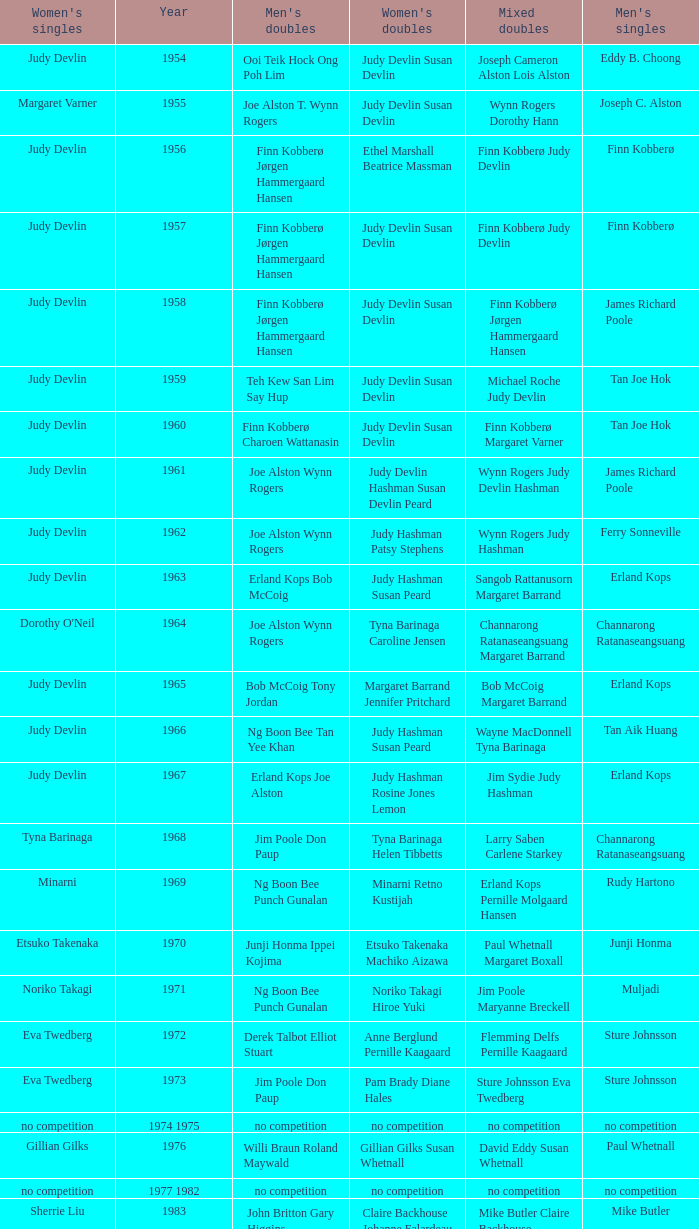Who were the men's doubles champions when the men's singles champion was muljadi? Ng Boon Bee Punch Gunalan. Can you give me this table as a dict? {'header': ["Women's singles", 'Year', "Men's doubles", "Women's doubles", 'Mixed doubles', "Men's singles"], 'rows': [['Judy Devlin', '1954', 'Ooi Teik Hock Ong Poh Lim', 'Judy Devlin Susan Devlin', 'Joseph Cameron Alston Lois Alston', 'Eddy B. Choong'], ['Margaret Varner', '1955', 'Joe Alston T. Wynn Rogers', 'Judy Devlin Susan Devlin', 'Wynn Rogers Dorothy Hann', 'Joseph C. Alston'], ['Judy Devlin', '1956', 'Finn Kobberø Jørgen Hammergaard Hansen', 'Ethel Marshall Beatrice Massman', 'Finn Kobberø Judy Devlin', 'Finn Kobberø'], ['Judy Devlin', '1957', 'Finn Kobberø Jørgen Hammergaard Hansen', 'Judy Devlin Susan Devlin', 'Finn Kobberø Judy Devlin', 'Finn Kobberø'], ['Judy Devlin', '1958', 'Finn Kobberø Jørgen Hammergaard Hansen', 'Judy Devlin Susan Devlin', 'Finn Kobberø Jørgen Hammergaard Hansen', 'James Richard Poole'], ['Judy Devlin', '1959', 'Teh Kew San Lim Say Hup', 'Judy Devlin Susan Devlin', 'Michael Roche Judy Devlin', 'Tan Joe Hok'], ['Judy Devlin', '1960', 'Finn Kobberø Charoen Wattanasin', 'Judy Devlin Susan Devlin', 'Finn Kobberø Margaret Varner', 'Tan Joe Hok'], ['Judy Devlin', '1961', 'Joe Alston Wynn Rogers', 'Judy Devlin Hashman Susan Devlin Peard', 'Wynn Rogers Judy Devlin Hashman', 'James Richard Poole'], ['Judy Devlin', '1962', 'Joe Alston Wynn Rogers', 'Judy Hashman Patsy Stephens', 'Wynn Rogers Judy Hashman', 'Ferry Sonneville'], ['Judy Devlin', '1963', 'Erland Kops Bob McCoig', 'Judy Hashman Susan Peard', 'Sangob Rattanusorn Margaret Barrand', 'Erland Kops'], ["Dorothy O'Neil", '1964', 'Joe Alston Wynn Rogers', 'Tyna Barinaga Caroline Jensen', 'Channarong Ratanaseangsuang Margaret Barrand', 'Channarong Ratanaseangsuang'], ['Judy Devlin', '1965', 'Bob McCoig Tony Jordan', 'Margaret Barrand Jennifer Pritchard', 'Bob McCoig Margaret Barrand', 'Erland Kops'], ['Judy Devlin', '1966', 'Ng Boon Bee Tan Yee Khan', 'Judy Hashman Susan Peard', 'Wayne MacDonnell Tyna Barinaga', 'Tan Aik Huang'], ['Judy Devlin', '1967', 'Erland Kops Joe Alston', 'Judy Hashman Rosine Jones Lemon', 'Jim Sydie Judy Hashman', 'Erland Kops'], ['Tyna Barinaga', '1968', 'Jim Poole Don Paup', 'Tyna Barinaga Helen Tibbetts', 'Larry Saben Carlene Starkey', 'Channarong Ratanaseangsuang'], ['Minarni', '1969', 'Ng Boon Bee Punch Gunalan', 'Minarni Retno Kustijah', 'Erland Kops Pernille Molgaard Hansen', 'Rudy Hartono'], ['Etsuko Takenaka', '1970', 'Junji Honma Ippei Kojima', 'Etsuko Takenaka Machiko Aizawa', 'Paul Whetnall Margaret Boxall', 'Junji Honma'], ['Noriko Takagi', '1971', 'Ng Boon Bee Punch Gunalan', 'Noriko Takagi Hiroe Yuki', 'Jim Poole Maryanne Breckell', 'Muljadi'], ['Eva Twedberg', '1972', 'Derek Talbot Elliot Stuart', 'Anne Berglund Pernille Kaagaard', 'Flemming Delfs Pernille Kaagaard', 'Sture Johnsson'], ['Eva Twedberg', '1973', 'Jim Poole Don Paup', 'Pam Brady Diane Hales', 'Sture Johnsson Eva Twedberg', 'Sture Johnsson'], ['no competition', '1974 1975', 'no competition', 'no competition', 'no competition', 'no competition'], ['Gillian Gilks', '1976', 'Willi Braun Roland Maywald', 'Gillian Gilks Susan Whetnall', 'David Eddy Susan Whetnall', 'Paul Whetnall'], ['no competition', '1977 1982', 'no competition', 'no competition', 'no competition', 'no competition'], ['Sherrie Liu', '1983', 'John Britton Gary Higgins', 'Claire Backhouse Johanne Falardeau', 'Mike Butler Claire Backhouse', 'Mike Butler'], ['Luo Yun', '1984', 'Chen Hongyong Zhang Qingwu', 'Yin Haichen Lu Yanahua', 'Wang Pengren Luo Yun', 'Xiong Guobao'], ['Claire Backhouse Sharpe', '1985', 'John Britton Gary Higgins', 'Claire Sharpe Sandra Skillings', 'Mike Butler Claire Sharpe', 'Mike Butler'], ['Denyse Julien', '1986', 'Yao Ximing Tariq Wadood', 'Denyse Julien Johanne Falardeau', 'Mike Butler Johanne Falardeau', 'Sung Han-kuk'], ['Chun Suk-sun', '1987', 'Lee Deuk-choon Lee Sang-bok', 'Kim Ho Ja Chung So-young', 'Lee Deuk-choon Chung So-young', 'Park Sun-bae'], ['Lee Myeong-hee', '1988', 'Christian Hadinata Lius Pongoh', 'Kim Ho Ja Chung So-young', 'Christian Hadinata Ivana Lie', 'Sze Yu'], ['no competition', '1989', 'no competition', 'no competition', 'no competition', 'no competition'], ['Denyse Julien', '1990', 'Ger Shin-Ming Yang Shih-Jeng', 'Denyse Julien Doris Piché', 'Tariq Wadood Traci Britton', 'Fung Permadi'], ['Shim Eun-jung', '1991', 'Jalani Sidek Razif Sidek', 'Shim Eun-jung Kang Bok-seung', 'Lee Sang-bok Shim Eun-jung', 'Steve Butler'], ['Lim Xiaoqing', '1992', 'Cheah Soon Kit Soo Beng Kiang', 'Lim Xiaoqing Christine Magnusson', 'Thomas Lund Pernille Dupont', 'Poul-Erik Hoyer-Larsen'], ['Lim Xiaoqing', '1993', 'Thomas Lund Jon Holst-Christensen', 'Gil Young-ah Chung So-young', 'Thomas Lund Catrine Bengtsson', 'Marleve Mainaky'], ['Liu Guimei', '1994', 'Ade Sutrisna Candra Wijaya', 'Rikke Olsen Helene Kirkegaard', 'Jens Eriksen Rikke Olsen', 'Thomas Stuer-Lauridsen'], ['Ye Zhaoying', '1995', 'Rudy Gunawan Joko Suprianto', 'Gil Young-ah Jang Hye-ock', 'Kim Dong-moon Gil Young-ah', 'Hermawan Susanto'], ['Mia Audina', '1996', 'Candra Wijaya Sigit Budiarto', 'Zelin Resiana Eliza Nathanael', 'Kim Dong-moon Chung So-young', 'Joko Suprianto'], ['Camilla Martin', '1997', 'Ha Tae-kwon Kim Dong-moon', 'Qin Yiyuan Tang Yongshu', 'Kim Dong Moon Ra Kyung-min', 'Poul-Erik Hoyer-Larsen'], ['Tang Yeping', '1998', 'Horng Shin-Jeng Lee Wei-Jen', 'Elinor Middlemiss Kirsteen McEwan', 'Kenny Middlemiss Elinor Middlemiss', 'Fung Permadi'], ['Pi Hongyan', '1999', 'Michael Lamp Jonas Rasmussen', 'Huang Nanyan Lu Ying', 'Jonas Rasmussen Jane F. Bramsen', 'Colin Haughton'], ['Choi Ma-re', '2000', 'Graham Hurrell James Anderson', 'Gail Emms Joanne Wright', 'Jonas Rasmussen Jane F. Bramsen', 'Ardy Wiranata'], ['Ra Kyung-min', '2001', 'Kang Kyung-jin Park Young-duk', 'Kim Kyeung-ran Ra Kyung-min', 'Mathias Boe Majken Vange', 'Lee Hyun-il'], ['Julia Mann', '2002', 'Tony Gunawan Khan Malaythong', 'Joanne Wright Natalie Munt', 'Tony Gunawan Etty Tantri', 'Peter Gade'], ['Kelly Morgan', '2003', 'Tony Gunawan Khan Malaythong', 'Yoshiko Iwata Miyuki Tai', 'Tony Gunawan Eti Gunawan', 'Chien Yu-hsiu'], ['Xing Aiying', '2004', 'Howard Bach Tony Gunawan', 'Cheng Wen-hsing Chien Yu-chin', 'Lin Wei-hsiang Cheng Wen-hsing', 'Kendrick Lee Yen Hui'], ['Lili Zhou', '2005', 'Howard Bach Tony Gunawan', 'Peng Yun Johanna Lee', 'Khan Malaythong Mesinee Mangkalakiri', 'Hsieh Yu-hsing'], ['Ella Karachkova', '2006', 'Halim Haryanto Tony Gunawan', 'Nina Vislova Valeria Sorokina', 'Sergey Ivlev Nina Vislova', 'Yousuke Nakanishi'], ['Jun Jae-youn', '2007', 'Tadashi Ohtsuka Keita Masuda', 'Miyuki Maeda Satoko Suetsuna', 'Keita Masuda Miyuki Maeda', 'Lee Tsuen Seng'], ['Lili Zhou', '2008', 'Howard Bach Khan Malaythong', 'Chang Li-Ying Hung Shih-Chieh', 'Halim Haryanto Peng Yun', 'Andrew Dabeka'], ['Anna Rice', '2009', 'Howard Bach Tony Gunawan', 'Ruilin Huang Xuelian Jiang', 'Howard Bach Eva Lee', 'Taufik Hidayat'], ['Zhu Lin', '2010', 'Fang Chieh-min Lee Sheng-mu', 'Cheng Wen-hsing Chien Yu-chin', 'Michael Fuchs Birgit Overzier', 'Rajiv Ouseph'], ['Tai Tzu-ying', '2011', 'Ko Sung-hyun Lee Yong-dae', 'Ha Jung-eun Kim Min-jung', 'Lee Yong-dae Ha Jung-eun', 'Sho Sasaki'], ['Pai Hsiao-ma', '2012', 'Hiroyuki Endo Kenichi Hayakawa', 'Misaki Matsutomo Ayaka Takahashi', 'Tony Gunawan Vita Marissa', 'Vladimir Ivanov'], ['Sapsiree Taerattanachai', '2013', 'Takeshi Kamura Keigo Sonoda', 'Bao Yixin Zhong Qianxin', 'Lee Chun Hei Chau Hoi Wah', 'Nguyen Tien Minh']]} 